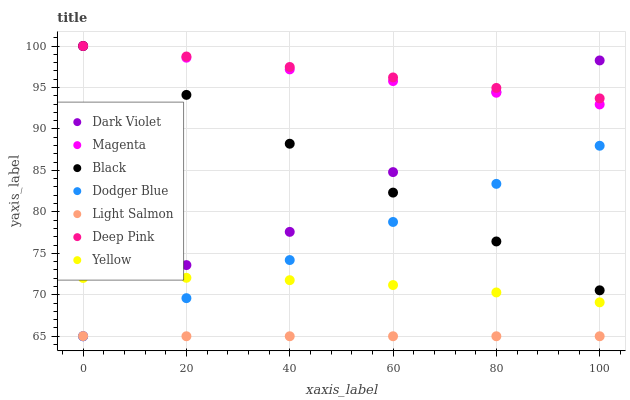Does Light Salmon have the minimum area under the curve?
Answer yes or no. Yes. Does Deep Pink have the maximum area under the curve?
Answer yes or no. Yes. Does Dark Violet have the minimum area under the curve?
Answer yes or no. No. Does Dark Violet have the maximum area under the curve?
Answer yes or no. No. Is Black the smoothest?
Answer yes or no. Yes. Is Dark Violet the roughest?
Answer yes or no. Yes. Is Deep Pink the smoothest?
Answer yes or no. No. Is Deep Pink the roughest?
Answer yes or no. No. Does Light Salmon have the lowest value?
Answer yes or no. Yes. Does Deep Pink have the lowest value?
Answer yes or no. No. Does Magenta have the highest value?
Answer yes or no. Yes. Does Dark Violet have the highest value?
Answer yes or no. No. Is Light Salmon less than Deep Pink?
Answer yes or no. Yes. Is Black greater than Light Salmon?
Answer yes or no. Yes. Does Dodger Blue intersect Dark Violet?
Answer yes or no. Yes. Is Dodger Blue less than Dark Violet?
Answer yes or no. No. Is Dodger Blue greater than Dark Violet?
Answer yes or no. No. Does Light Salmon intersect Deep Pink?
Answer yes or no. No. 